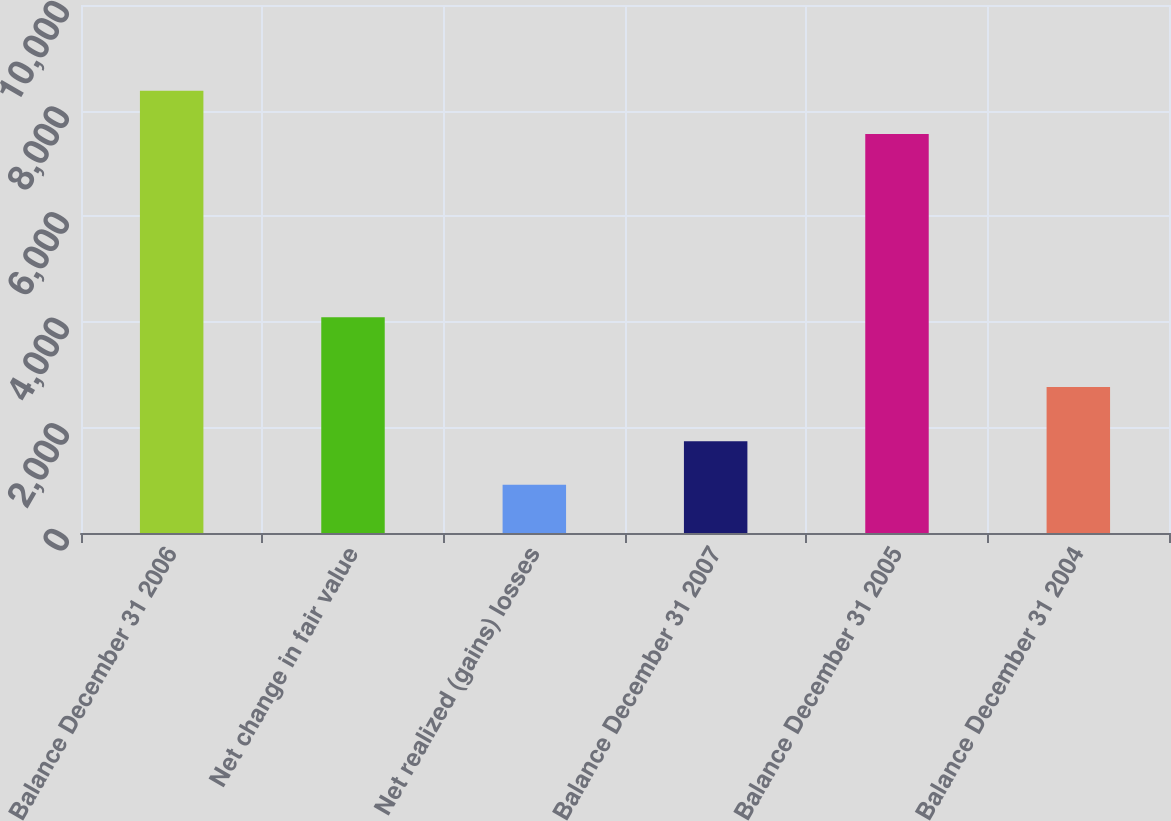Convert chart. <chart><loc_0><loc_0><loc_500><loc_500><bar_chart><fcel>Balance December 31 2006<fcel>Net change in fair value<fcel>Net realized (gains) losses<fcel>Balance December 31 2007<fcel>Balance December 31 2005<fcel>Balance December 31 2004<nl><fcel>8377.8<fcel>4084<fcel>913.8<fcel>1735.6<fcel>7556<fcel>2764<nl></chart> 